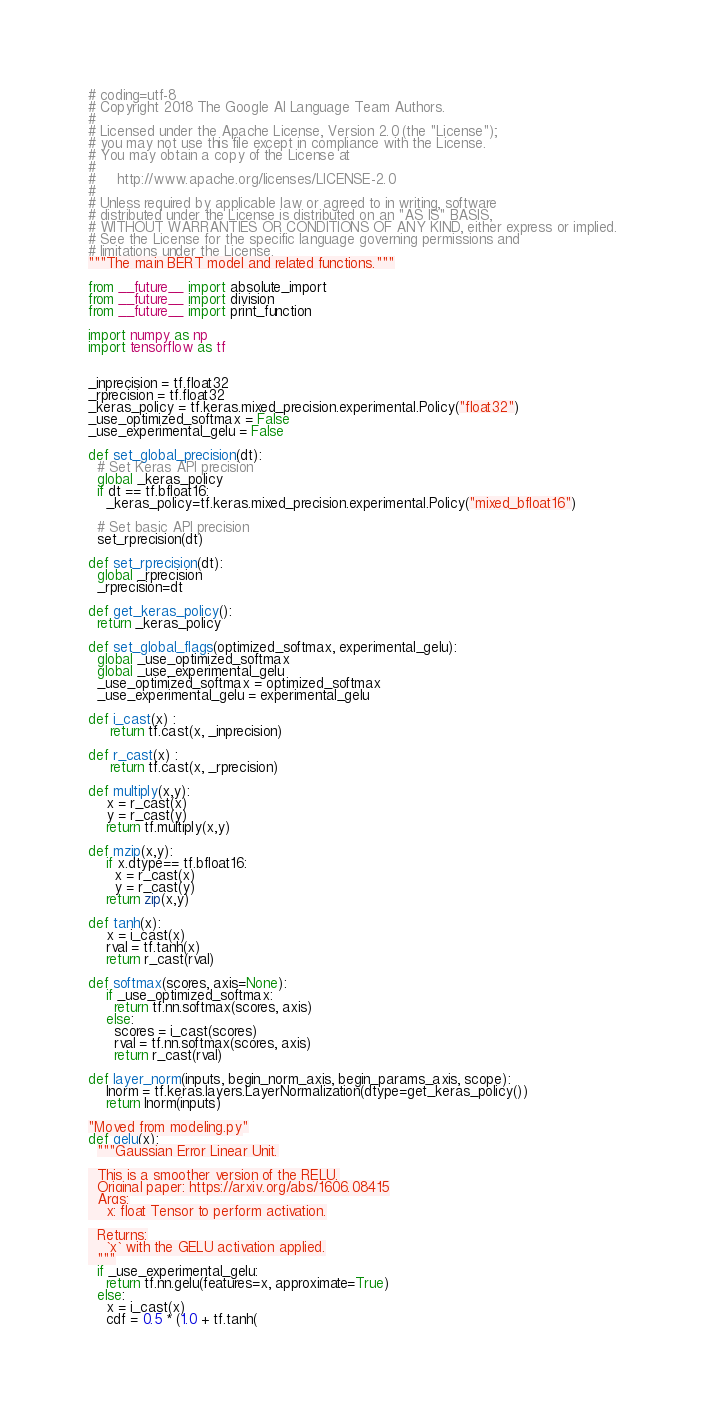Convert code to text. <code><loc_0><loc_0><loc_500><loc_500><_Python_># coding=utf-8
# Copyright 2018 The Google AI Language Team Authors.
#
# Licensed under the Apache License, Version 2.0 (the "License");
# you may not use this file except in compliance with the License.
# You may obtain a copy of the License at
#
#     http://www.apache.org/licenses/LICENSE-2.0
#
# Unless required by applicable law or agreed to in writing, software
# distributed under the License is distributed on an "AS IS" BASIS,
# WITHOUT WARRANTIES OR CONDITIONS OF ANY KIND, either express or implied.
# See the License for the specific language governing permissions and
# limitations under the License.
"""The main BERT model and related functions."""

from __future__ import absolute_import
from __future__ import division
from __future__ import print_function

import numpy as np
import tensorflow as tf


_inprecision = tf.float32
_rprecision = tf.float32
_keras_policy = tf.keras.mixed_precision.experimental.Policy("float32")
_use_optimized_softmax = False
_use_experimental_gelu = False

def set_global_precision(dt):
  # Set Keras API precision
  global _keras_policy
  if dt == tf.bfloat16:
    _keras_policy=tf.keras.mixed_precision.experimental.Policy("mixed_bfloat16")

  # Set basic API precision
  set_rprecision(dt)

def set_rprecision(dt):
  global _rprecision
  _rprecision=dt

def get_keras_policy():
  return _keras_policy

def set_global_flags(optimized_softmax, experimental_gelu):
  global _use_optimized_softmax
  global _use_experimental_gelu
  _use_optimized_softmax = optimized_softmax
  _use_experimental_gelu = experimental_gelu

def i_cast(x) :
     return tf.cast(x, _inprecision)

def r_cast(x) :
     return tf.cast(x, _rprecision)

def multiply(x,y):
    x = r_cast(x)
    y = r_cast(y)
    return tf.multiply(x,y)

def mzip(x,y):
    if x.dtype== tf.bfloat16:
      x = r_cast(x)
      y = r_cast(y)
    return zip(x,y)

def tanh(x):
    x = i_cast(x)
    rval = tf.tanh(x)
    return r_cast(rval)

def softmax(scores, axis=None):
    if _use_optimized_softmax:
      return tf.nn.softmax(scores, axis)
    else:
      scores = i_cast(scores)
      rval = tf.nn.softmax(scores, axis)
      return r_cast(rval)

def layer_norm(inputs, begin_norm_axis, begin_params_axis, scope):
    lnorm = tf.keras.layers.LayerNormalization(dtype=get_keras_policy())
    return lnorm(inputs)

"Moved from modeling.py"
def gelu(x):
  """Gaussian Error Linear Unit.

  This is a smoother version of the RELU.
  Original paper: https://arxiv.org/abs/1606.08415
  Args:
    x: float Tensor to perform activation.

  Returns:
    `x` with the GELU activation applied.
  """
  if _use_experimental_gelu:
    return tf.nn.gelu(features=x, approximate=True)
  else:
    x = i_cast(x)
    cdf = 0.5 * (1.0 + tf.tanh(</code> 